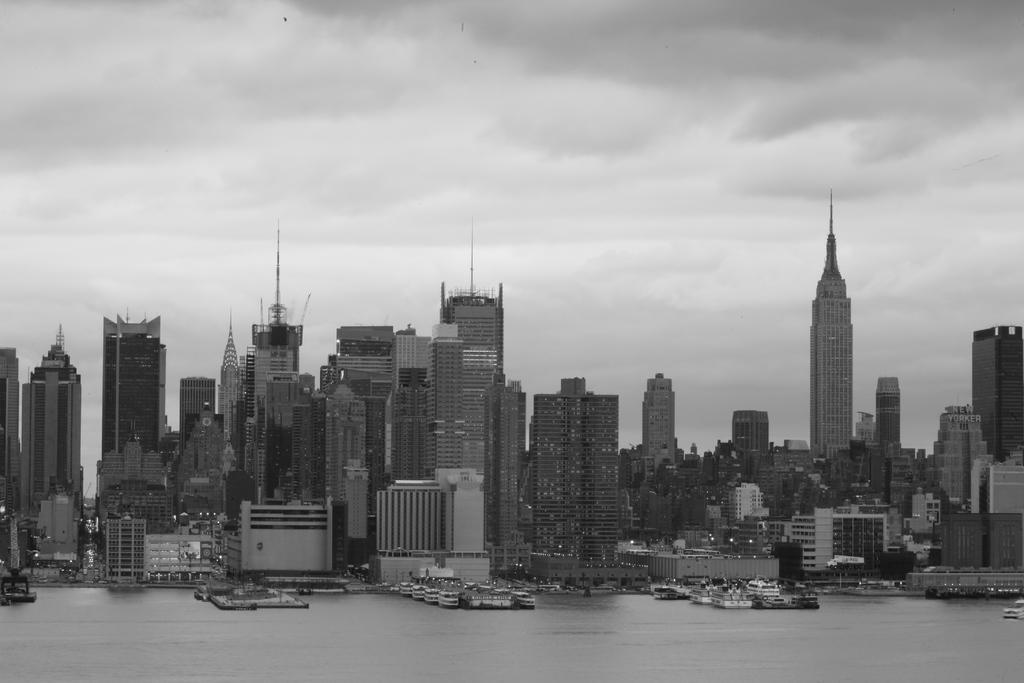Please provide a concise description of this image. In the center of the image there are buildings. At the bottom there is water and we can see boats on the water. In the background there is sky. 